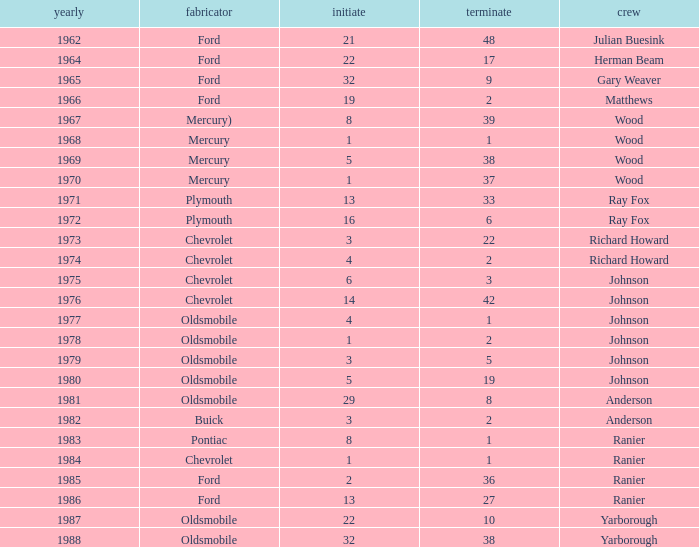What is the smallest finish time for a race after 1972 with a car manufactured by pontiac? 1.0. 